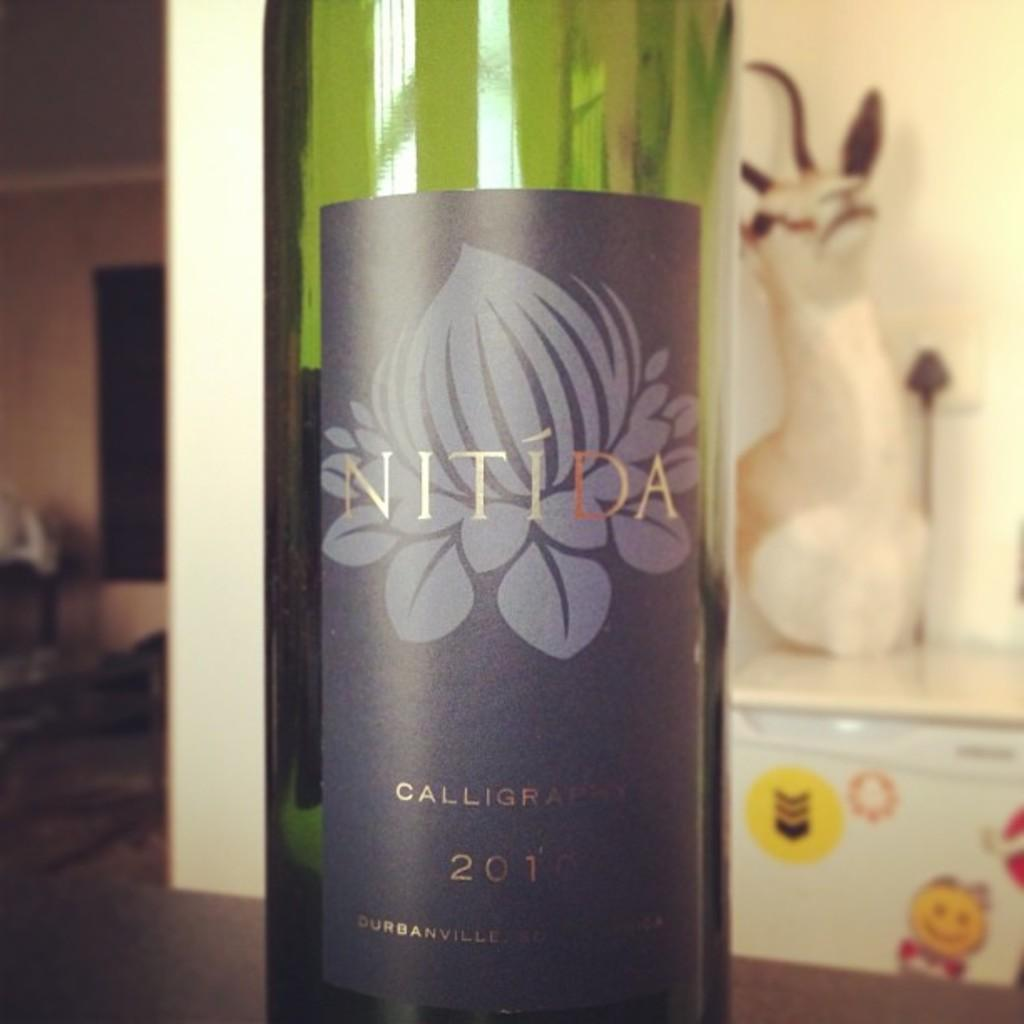What object can be seen in the picture? There is a bottle in the picture. What is on the bottle? The bottle has a sticker on it. What can be seen in the background of the image? There is a toy and cable on a rack in the background of the image. What type of popcorn is being served in the cellar in the image? There is no popcorn or cellar present in the image; it only features a bottle with a sticker and a toy and cable on a rack in the background. 